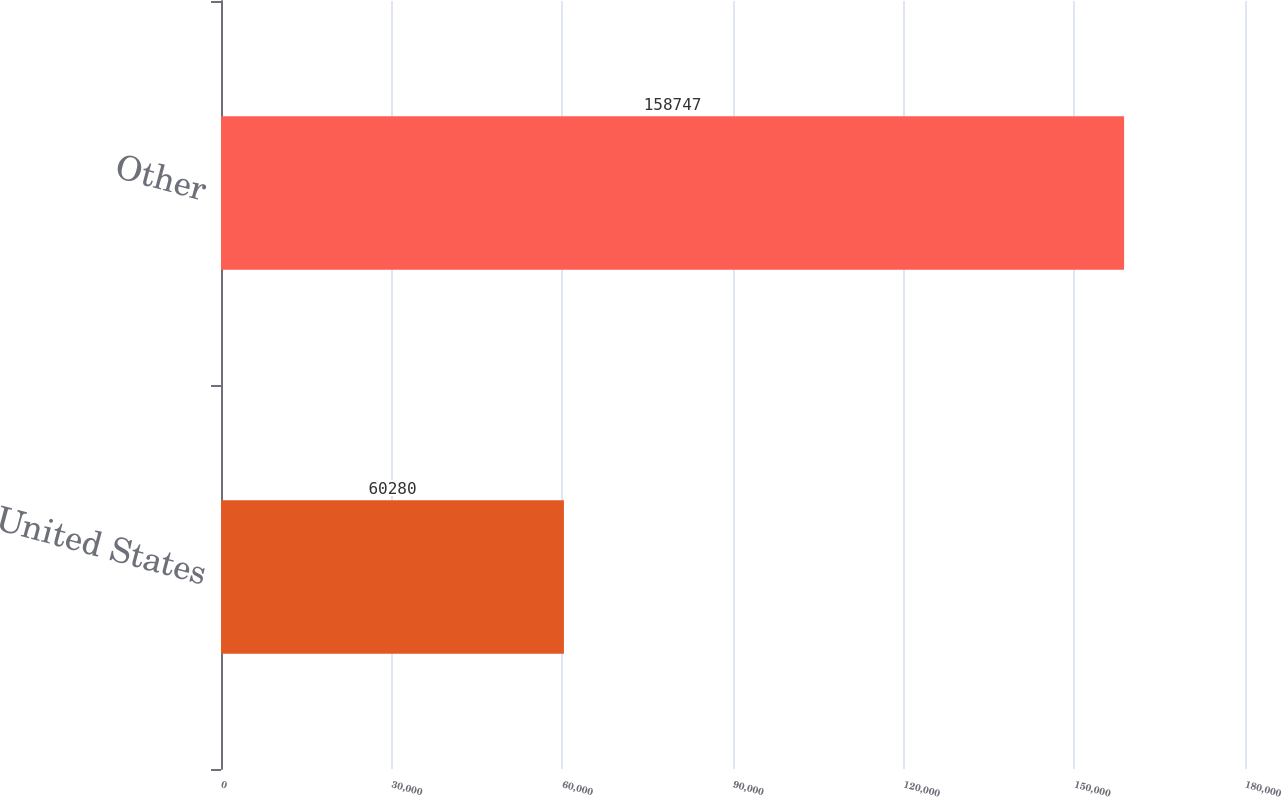Convert chart. <chart><loc_0><loc_0><loc_500><loc_500><bar_chart><fcel>United States<fcel>Other<nl><fcel>60280<fcel>158747<nl></chart> 